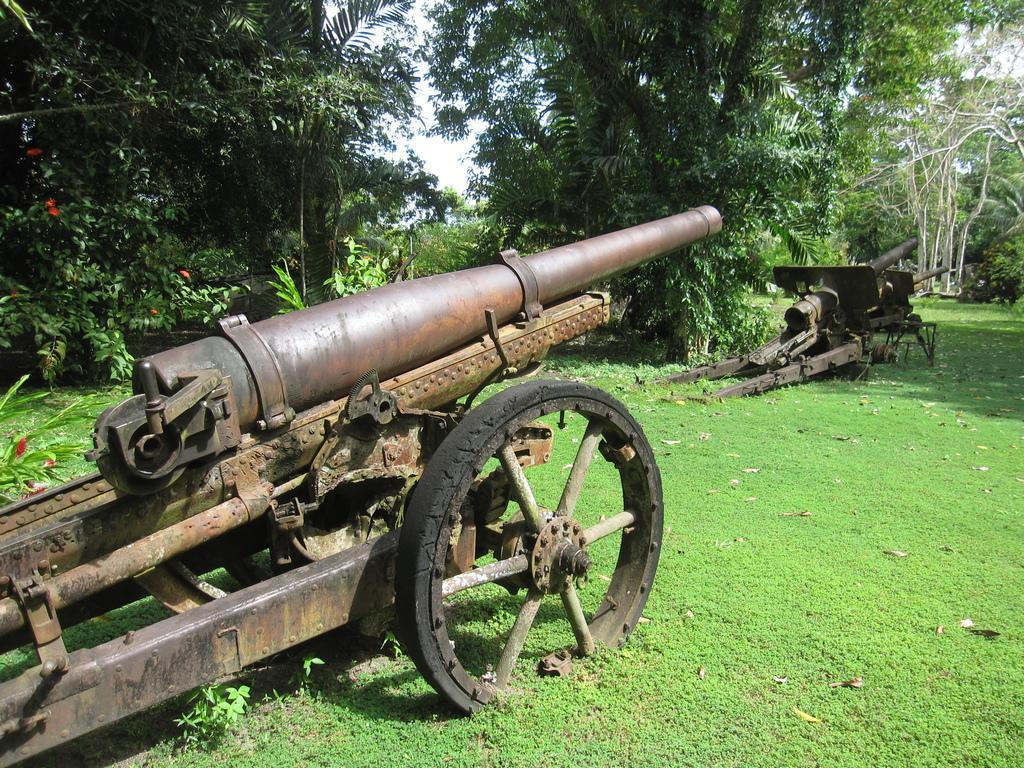How would you summarize this image in a sentence or two? In this image I can see and open grass ground and on it I can see few canons. In the background I can see number of trees and shadows on the ground. 